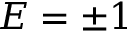<formula> <loc_0><loc_0><loc_500><loc_500>E = \pm 1</formula> 